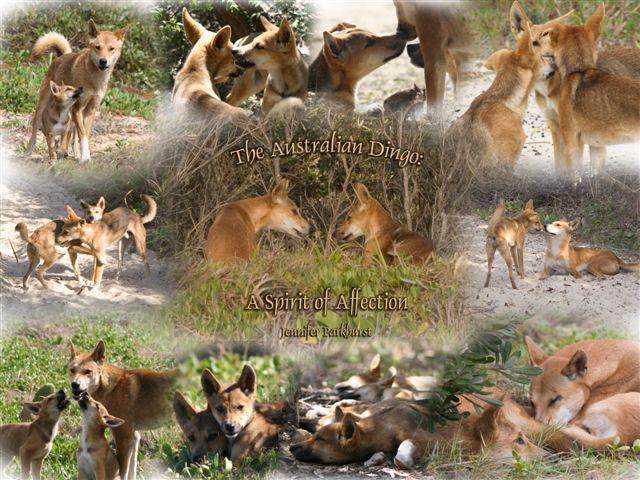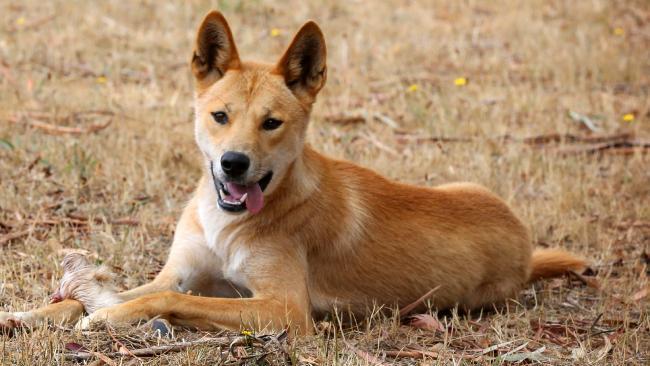The first image is the image on the left, the second image is the image on the right. For the images shown, is this caption "The right image features a single dog posed outdoors facing forwards." true? Answer yes or no. Yes. 